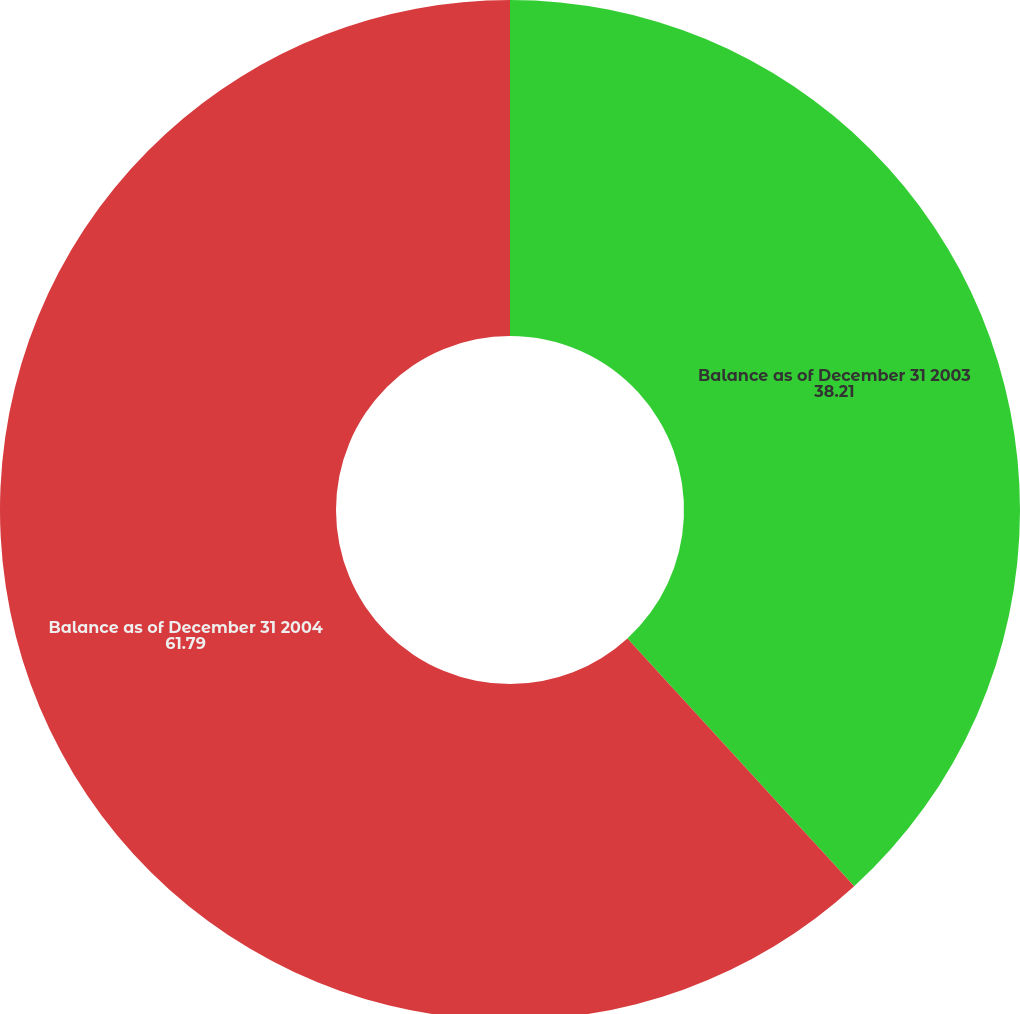<chart> <loc_0><loc_0><loc_500><loc_500><pie_chart><fcel>Balance as of December 31 2003<fcel>Balance as of December 31 2004<nl><fcel>38.21%<fcel>61.79%<nl></chart> 